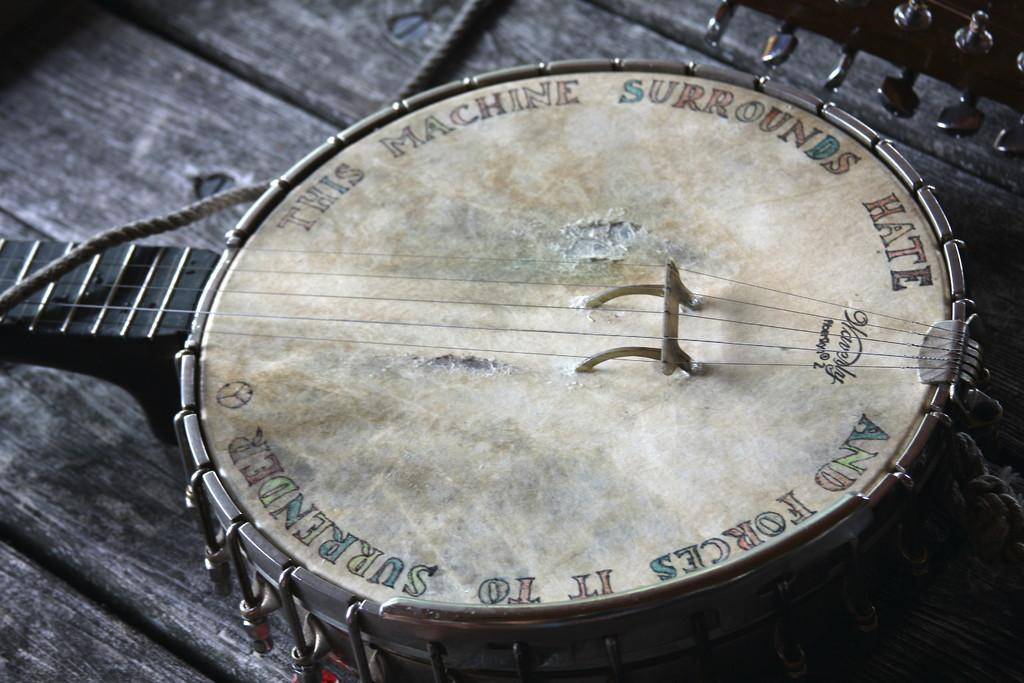What object in the image is associated with creating music? There is a musical instrument in the image. Where might the musical instrument be located in the image? The musical instrument may be on a table. What else can be seen in the image besides the musical instrument? There is text visible in the image. What type of van is parked next to the musical instrument in the image? There is no van present in the image; it only features a musical instrument and text. 